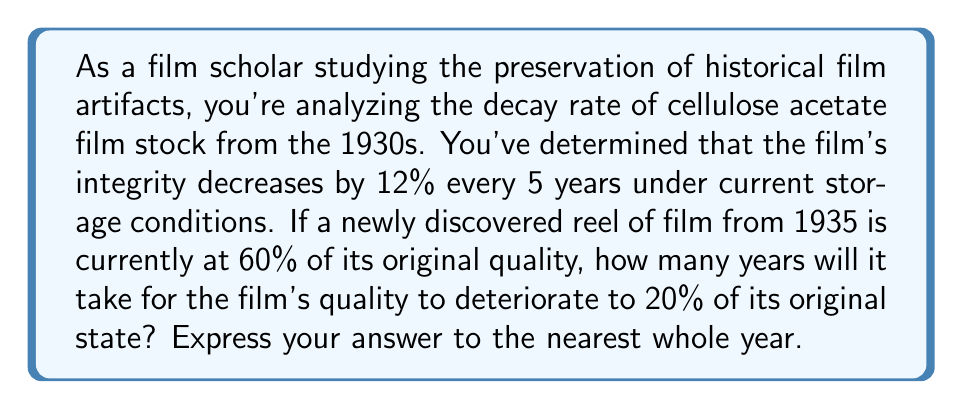Help me with this question. To solve this problem, we need to use the exponential decay formula and logarithms. Let's approach this step-by-step:

1) First, let's define our variables:
   - Initial quality: 60% (0.60 of original)
   - Final quality: 20% (0.20 of original)
   - Decay rate: 12% every 5 years

2) We need to find the decay rate per year. If it's 12% every 5 years, then:
   $r = 1 - (1 - 0.12)^{1/5} \approx 0.0254$ or about 2.54% per year

3) Now we can set up our exponential decay equation:
   $A = P(1-r)^t$
   Where:
   $A$ is the final amount (0.20)
   $P$ is the initial amount (0.60)
   $r$ is the decay rate per year (0.0254)
   $t$ is the time in years (what we're solving for)

4) Plugging in our values:
   $0.20 = 0.60(1-0.0254)^t$

5) To solve for $t$, we need to use logarithms. First, divide both sides by 0.60:
   $\frac{0.20}{0.60} = (1-0.0254)^t$
   $0.3333 = 0.9746^t$

6) Now take the natural log of both sides:
   $\ln(0.3333) = \ln(0.9746^t)$
   $\ln(0.3333) = t \cdot \ln(0.9746)$

7) Solve for $t$:
   $t = \frac{\ln(0.3333)}{\ln(0.9746)} \approx 44.7$ years

8) Rounding to the nearest whole year:
   $t = 45$ years
Answer: 45 years 